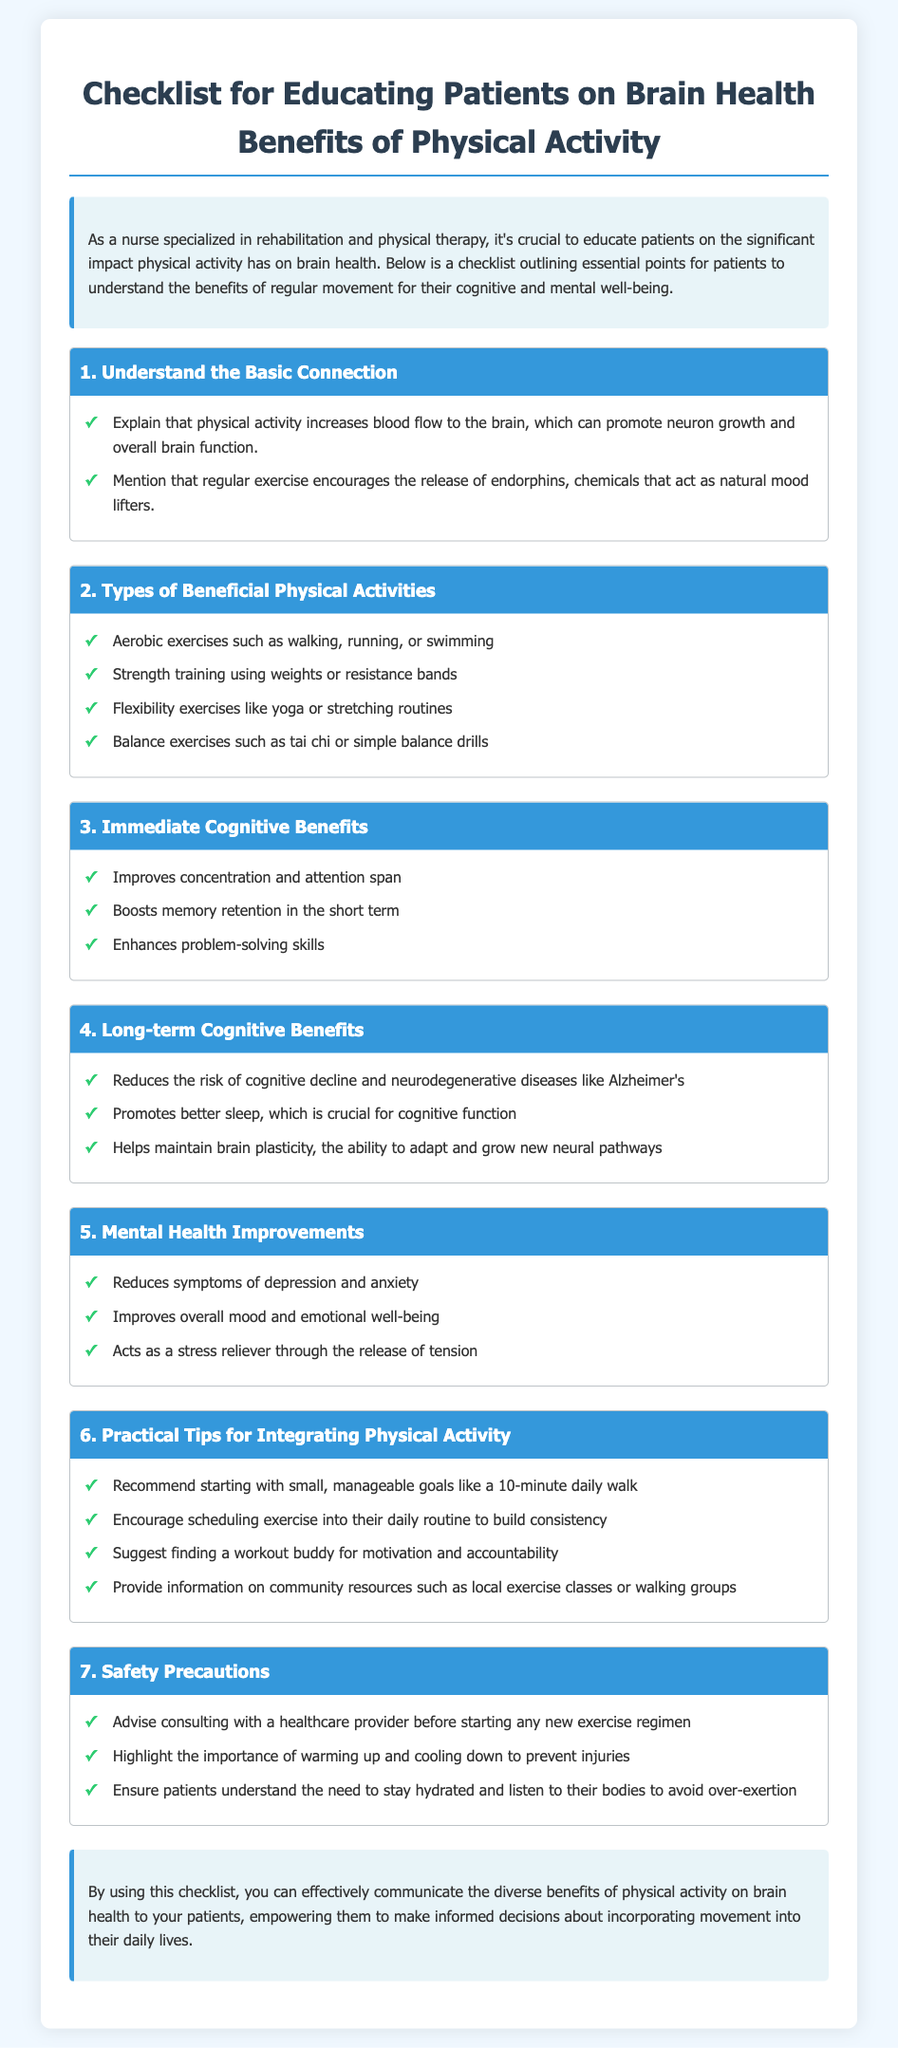What is the title of the checklist? The title is prominently displayed at the top of the document, clearly indicating the focus on educating patients about physical activity and brain health.
Answer: Checklist for Educating Patients on Brain Health Benefits of Physical Activity What is one type of aerobic exercise mentioned? The checklist specifies various types of physical activities, among which aerobic exercises are highlighted.
Answer: Walking What immediate benefit of physical activity is listed? The document outlines several immediate cognitive benefits under the relevant section, providing clear examples.
Answer: Improves concentration and attention span What is a long-term cognitive benefit of physical activity? The checklist specifically mentions long-term cognitive benefits, detailing the positive impacts on brain health over time.
Answer: Reduces the risk of cognitive decline What practical tip is suggested for integrating physical activity? One section of the checklist provides practical tips aimed at helping patients incorporate more physical activity into their lives.
Answer: Start with small, manageable goals Which safety precaution is advised? Within the checklist, safety precautions are highlighted to ensure that patients engage in physical activity safely and effectively.
Answer: Consult with a healthcare provider before starting any new exercise regimen What type of exercise does the checklist recommend for balance? The document includes a category for different types of beneficial physical activities, which encompasses balance exercises.
Answer: Tai chi What chemical is released during physical activity that acts as a mood lifter? The checklist explains various benefits of physical activity, specifically noting certain chemicals that contribute to mental well-being.
Answer: Endorphins 